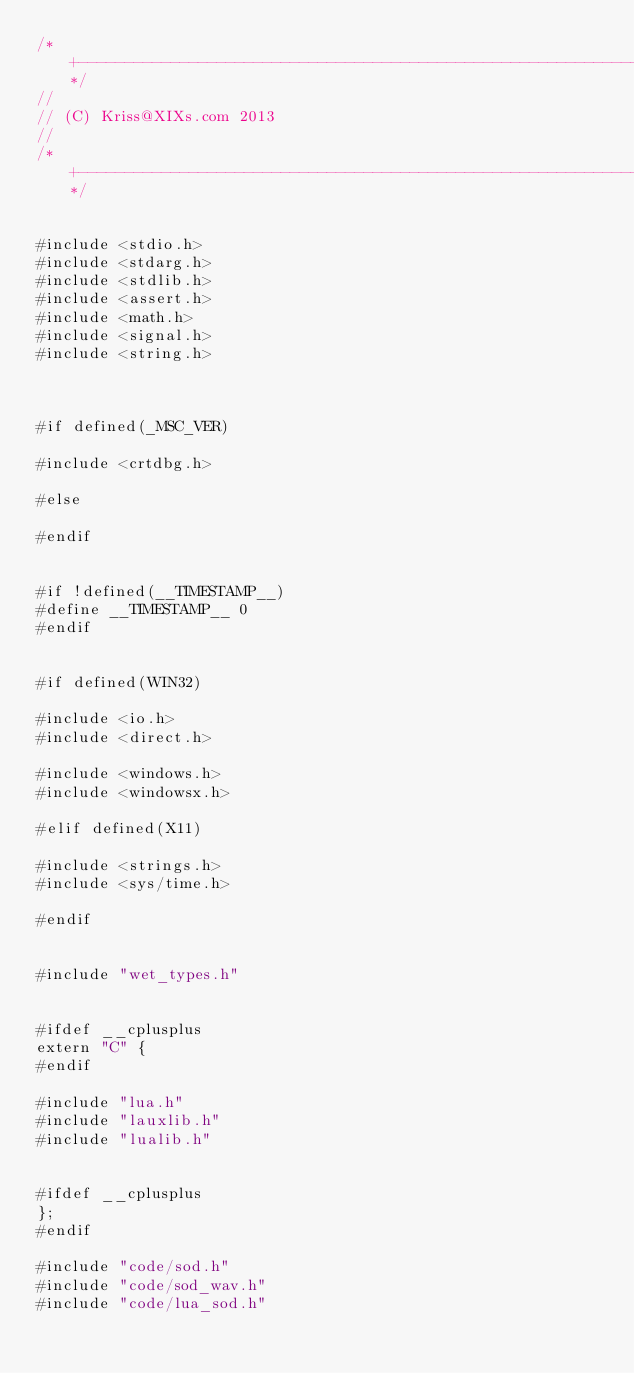Convert code to text. <code><loc_0><loc_0><loc_500><loc_500><_C_>/*+-----------------------------------------------------------------------------------------------------------------+*/
//
// (C) Kriss@XIXs.com 2013
//
/*+-----------------------------------------------------------------------------------------------------------------+*/


#include <stdio.h>
#include <stdarg.h>
#include <stdlib.h>
#include <assert.h>
#include <math.h>
#include <signal.h>
#include <string.h>



#if defined(_MSC_VER)

#include <crtdbg.h>

#else

#endif


#if !defined(__TIMESTAMP__)
#define __TIMESTAMP__ 0
#endif


#if defined(WIN32)

#include <io.h>
#include <direct.h>

#include <windows.h>
#include <windowsx.h>

#elif defined(X11)

#include <strings.h>
#include <sys/time.h>

#endif


#include "wet_types.h"


#ifdef __cplusplus
extern "C" {
#endif

#include "lua.h"
#include "lauxlib.h"
#include "lualib.h"


#ifdef __cplusplus
};
#endif

#include "code/sod.h"
#include "code/sod_wav.h"
#include "code/lua_sod.h"


</code> 